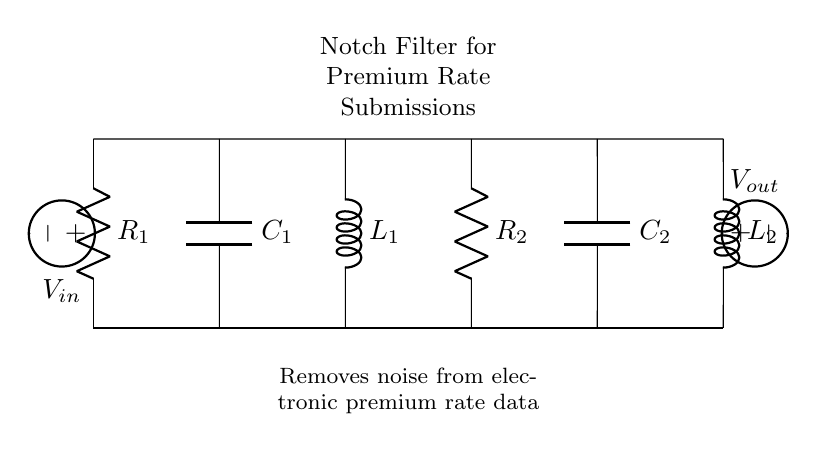What type of circuit is this? This circuit is identified as a notch filter, as indicated by the label on the circuit diagram. Notch filters are used to remove specific frequency components from a signal, often employed in noise reduction applications.
Answer: Notch filter What is the function of this circuit? The circuit's primary function is to remove noise from electronic premium rate submissions, as stated on the diagram. This implies that the circuit isolates undesirable frequency components that may interfere with the clarity or accuracy of the data.
Answer: Noise removal How many resistors are there in the circuit? The circuit contains two resistors, R1 and R2, as denoted by their respective labels in the diagram. The circuit structure shows both resistors connected in series with other components, which indicates that they are integral to the function.
Answer: Two What components are used in this notch filter? The circuit includes two resistors (R1, R2), two capacitors (C1, C2), and two inductors (L1, L2). Each component plays a role in filtering specific frequencies, with resistors controlling current, capacitors storing charge, and inductors opposing changes in current.
Answer: Resistors, capacitors, inductors What is the purpose of the capacitors in this notch filter? The capacitors (C1 and C2) in the notch filter serve to create a frequency-dependent impedance, allowing certain frequencies to pass while blocking others. This behavior is crucial in achieving the desired notch effect that is characteristic of this type of circuit.
Answer: Frequency-dependent impedance At what points does the input and output voltage occur? The input voltage \(V_{in}\) occurs at the left side of the circuit diagram (connected to R1), while the output voltage \(V_{out}\) is located on the right side (connected to L2). This layout shows how the filter processes the input signal to produce a filtered output.
Answer: Left and right sides 